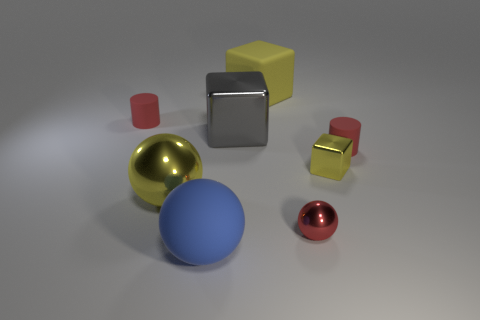Can you tell which of these objects is the foremost and why it appears to be so? The bright red sphere is the foremost object in the scene. It appears closer than the other objects due to its placement at the bottom of the image and its slightly larger relative size, which typically indicates it being closer to the viewer within a three-dimensional space. 